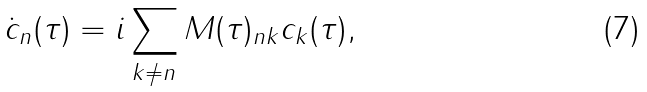Convert formula to latex. <formula><loc_0><loc_0><loc_500><loc_500>\dot { c } _ { n } ( \tau ) = i \sum _ { k \neq n } M ( \tau ) _ { n k } c _ { k } ( \tau ) ,</formula> 